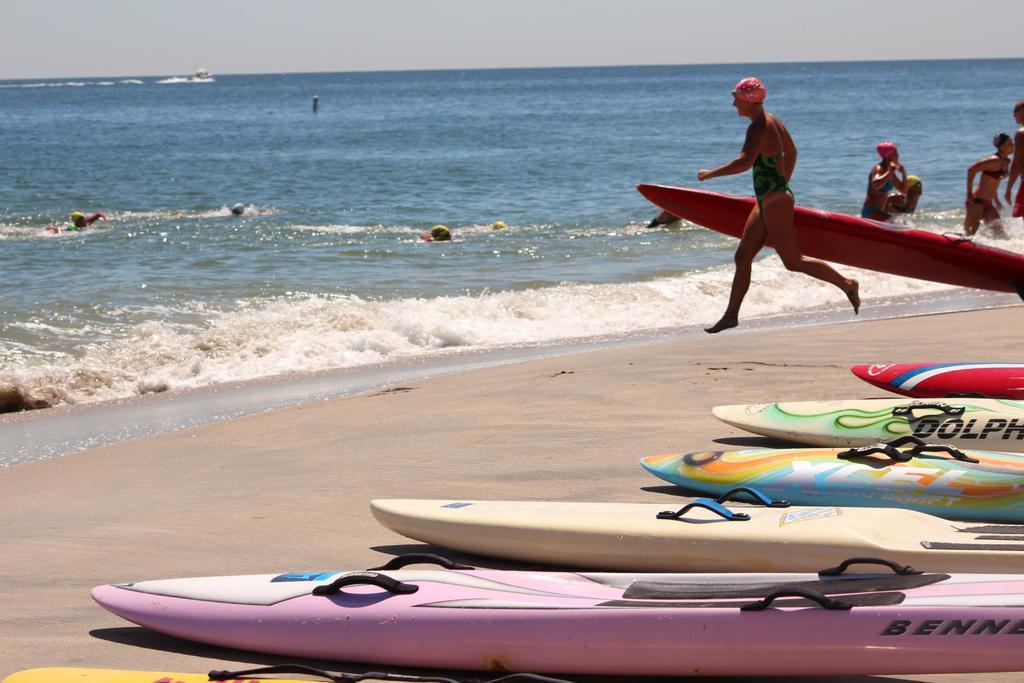What does the pink board say?
Provide a short and direct response. Benne. What does the second board say?
Make the answer very short. Dolph. 